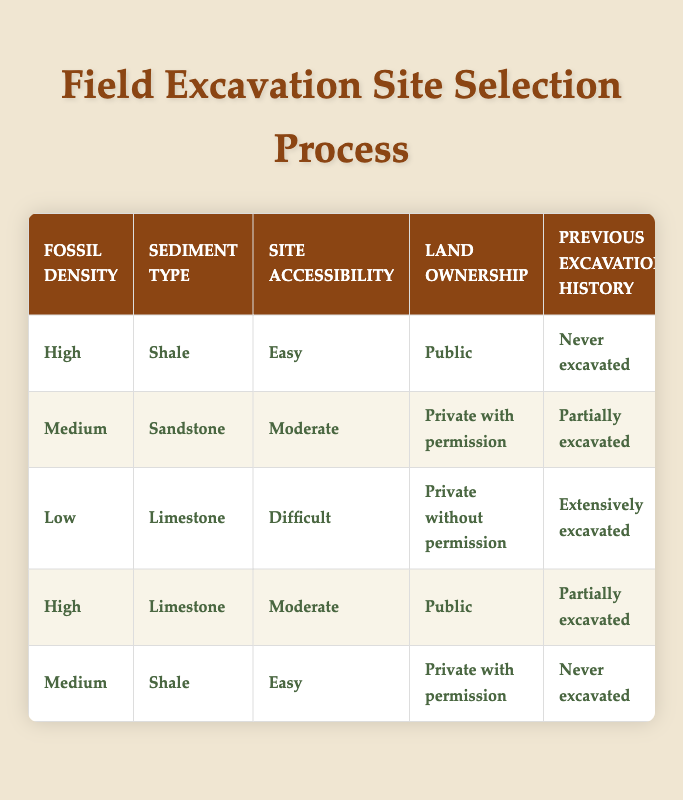What is the excavation priority for high fossil density in shale that is easy to access and publicly owned? In the table, we look for the row where fossil density is 'High', sediment type is 'Shale', site accessibility is 'Easy', and land ownership is 'Public'. We find the entry that matches these conditions, which has an excavation priority of 'High'.
Answer: High What equipment is required for medium fossil density in sandstone with moderate accessibility on private land with permission? We check the row that has fossil density as 'Medium', sediment type as 'Sandstone', site accessibility as 'Moderate', and land ownership as 'Private with permission'. This combination shows the required equipment as 'Heavy machinery'.
Answer: Heavy machinery Are there any sites with low fossil density and difficult accessibility that are privately owned without permission? We look for any entries with fossil density as 'Low', site accessibility as 'Difficult', and land ownership as 'Private without permission'. There is one such entry that confirms the conditions, thus the answer is 'Yes'.
Answer: Yes What is the average estimated excavation duration for all rows with high excavation priority? We need to find all entries that have 'High' as the excavation priority. There are two such entries with durations of '3-4 weeks' each. We treat '3-4 weeks' as an average of 3.5 weeks (or 24.5 days). Thereby, the average duration across high priority sites is 24.5 days.
Answer: 3.5 weeks If a site has been extensively excavated, what conservation measure is recommended? We review the rows where the 'Previous excavation history' is 'Extensively excavated'. One such row indicates that the conservation measure is 'Leave in situ' for sites that are difficult to access and privately owned without permission.
Answer: Leave in situ Which excavation team size is required for medium fossil density shale on private land with permission if it has never been excavated? In the table, we find the row with fossil density as 'Medium', sediment type as 'Shale', site accessibility as 'Easy', land ownership as 'Private with permission', and previous excavation history as 'Never excavated'. This shows that a 'Small team (2-4)' is required.
Answer: Small team (2-4) How long would it take to excavate a site with high fossil density in limestone that is moderately accessible and partially excavated? We locate the row that has 'High' fossil density, 'Limestone' sediment type, 'Moderate' site accessibility, and 'Partially excavated' in previous history. The estimated excavation duration in that row is '3-4 weeks'.
Answer: 3-4 weeks Is specialized tools necessary when excavating high fossil density limestone on public land with partial history? We check the specific conditions for high fossil density limestone, public land, and partial excavation history. The corresponding action states that 'Specialized tools' are indeed necessary.
Answer: Yes What conservation measure is typically employed for sites requiring a medium excavation priority with privately owned land and previously excavated partially? We analyze the entries with 'Medium' excavation priority, 'Private with permission' land ownership, and 'Partially excavated'. The relevant conservation measure listed there is 'Standard field jacket'.
Answer: Standard field jacket 